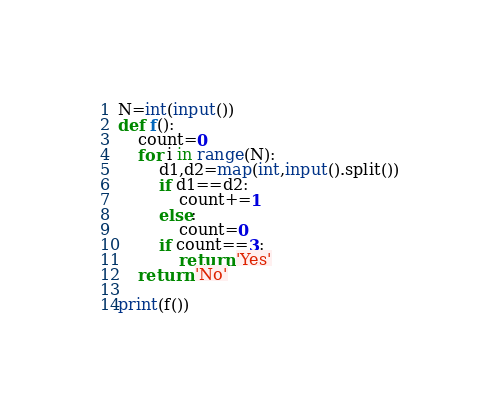<code> <loc_0><loc_0><loc_500><loc_500><_Python_>N=int(input())
def f():
    count=0
    for i in range(N):
        d1,d2=map(int,input().split())
        if d1==d2:
            count+=1
        else:
            count=0
        if count==3:
            return 'Yes'
    return 'No'

print(f())</code> 